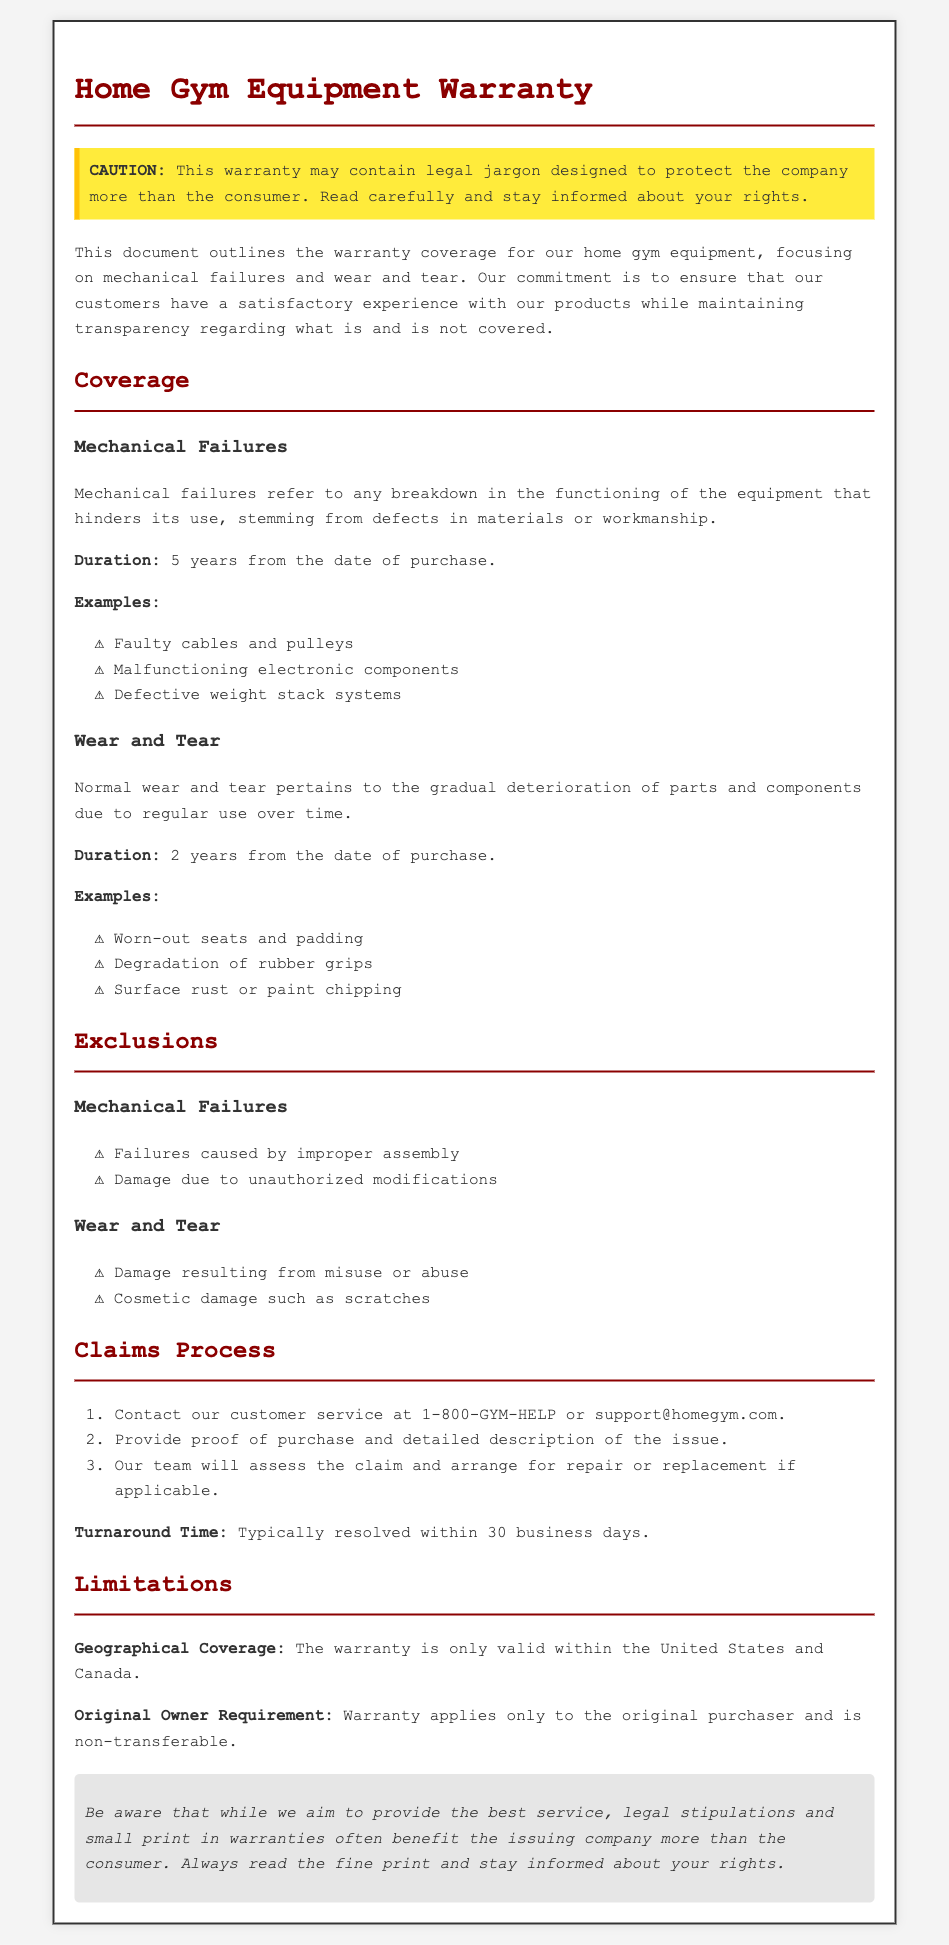What is the duration for mechanical failures coverage? The document states that the duration for mechanical failures is 5 years from the date of purchase.
Answer: 5 years What examples are listed under wear and tear? The document provides specific examples under wear and tear to illustrate what is covered. Examples include worn-out seats and padding, degradation of rubber grips, and surface rust or paint chipping.
Answer: Worn-out seats and padding, degradation of rubber grips, surface rust or paint chipping What must be provided to initiate a claims process? The claims process requires specific documentation and information to be provided by the customer. The document states that proof of purchase and a detailed description of the issue are needed.
Answer: Proof of purchase and detailed description of the issue What geographical regions does the warranty cover? The document specifies that the warranty is only valid within certain regions. It explicitly mentions the United States and Canada.
Answer: United States and Canada What should be done in case of improper assembly? The document includes exclusions for mechanical failures caused by improper assembly, indicating that such failures are not covered under warranty.
Answer: Not covered How long is the turnaround time for claims resolution? There is a specified timeframe mentioned in the claims section regarding how long it typically takes to resolve claims. It states that the typical resolution time is within a certain number of business days.
Answer: 30 business days Who does the warranty apply to? The limitations section of the document states that the warranty is applicable only to a specific type of owner related to the purchase of the equipment.
Answer: Original purchaser What kind of damages are excluded from wear and tear? The document provides exclusions for wear and tear. It states that damage resulting from misuse or abuse and cosmetic damage such as scratches are not covered.
Answer: Misuse or abuse, cosmetic damage such as scratches 